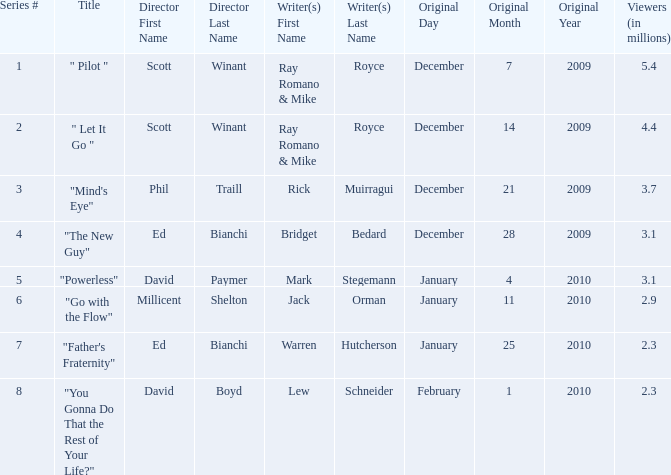What is the episode number of  "you gonna do that the rest of your life?" 8.0. 